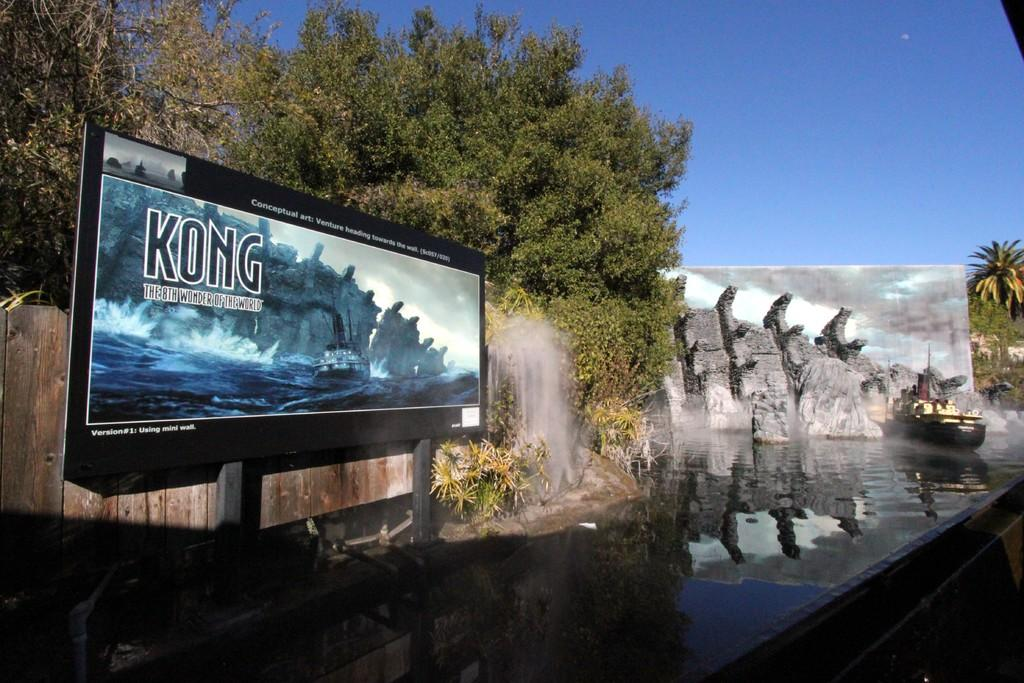<image>
Describe the image concisely. A billboard states that Kong is the eighth wonder of the world. 